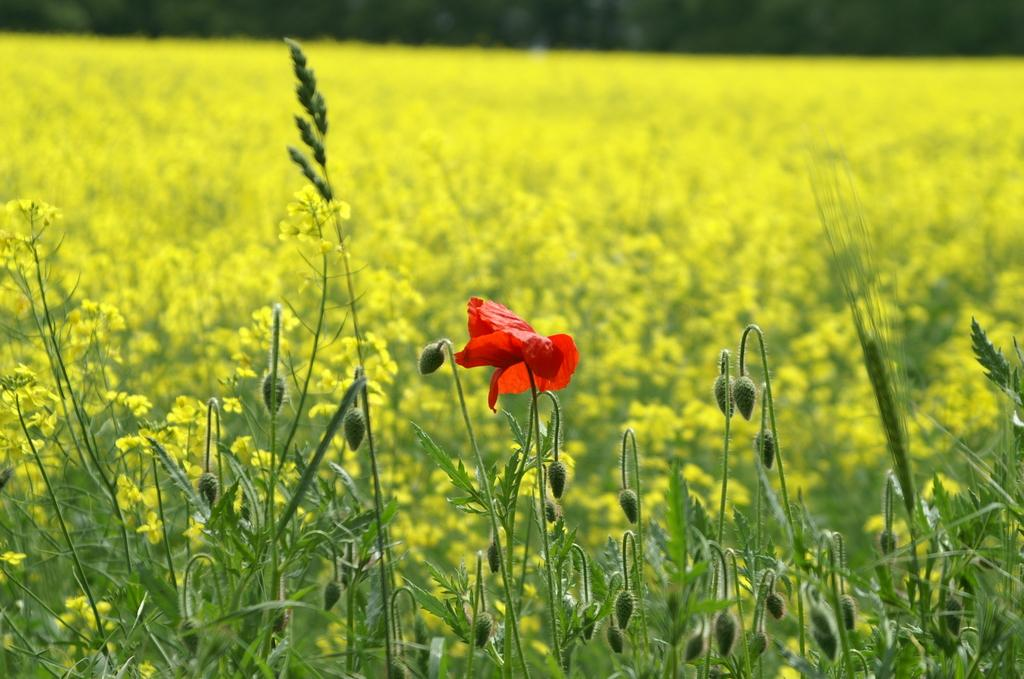What is the main subject in the center of the image? There is a flower on a plant in the center of the image. What can be seen at the bottom of the image? There are plants and flowers at the bottom of the image. What is visible in the background of the image? There are plants and flowers in the background of the image. Can you tell me who is talking to the flower in the image? There is no person present in the image, so there is no one talking to the flower. 